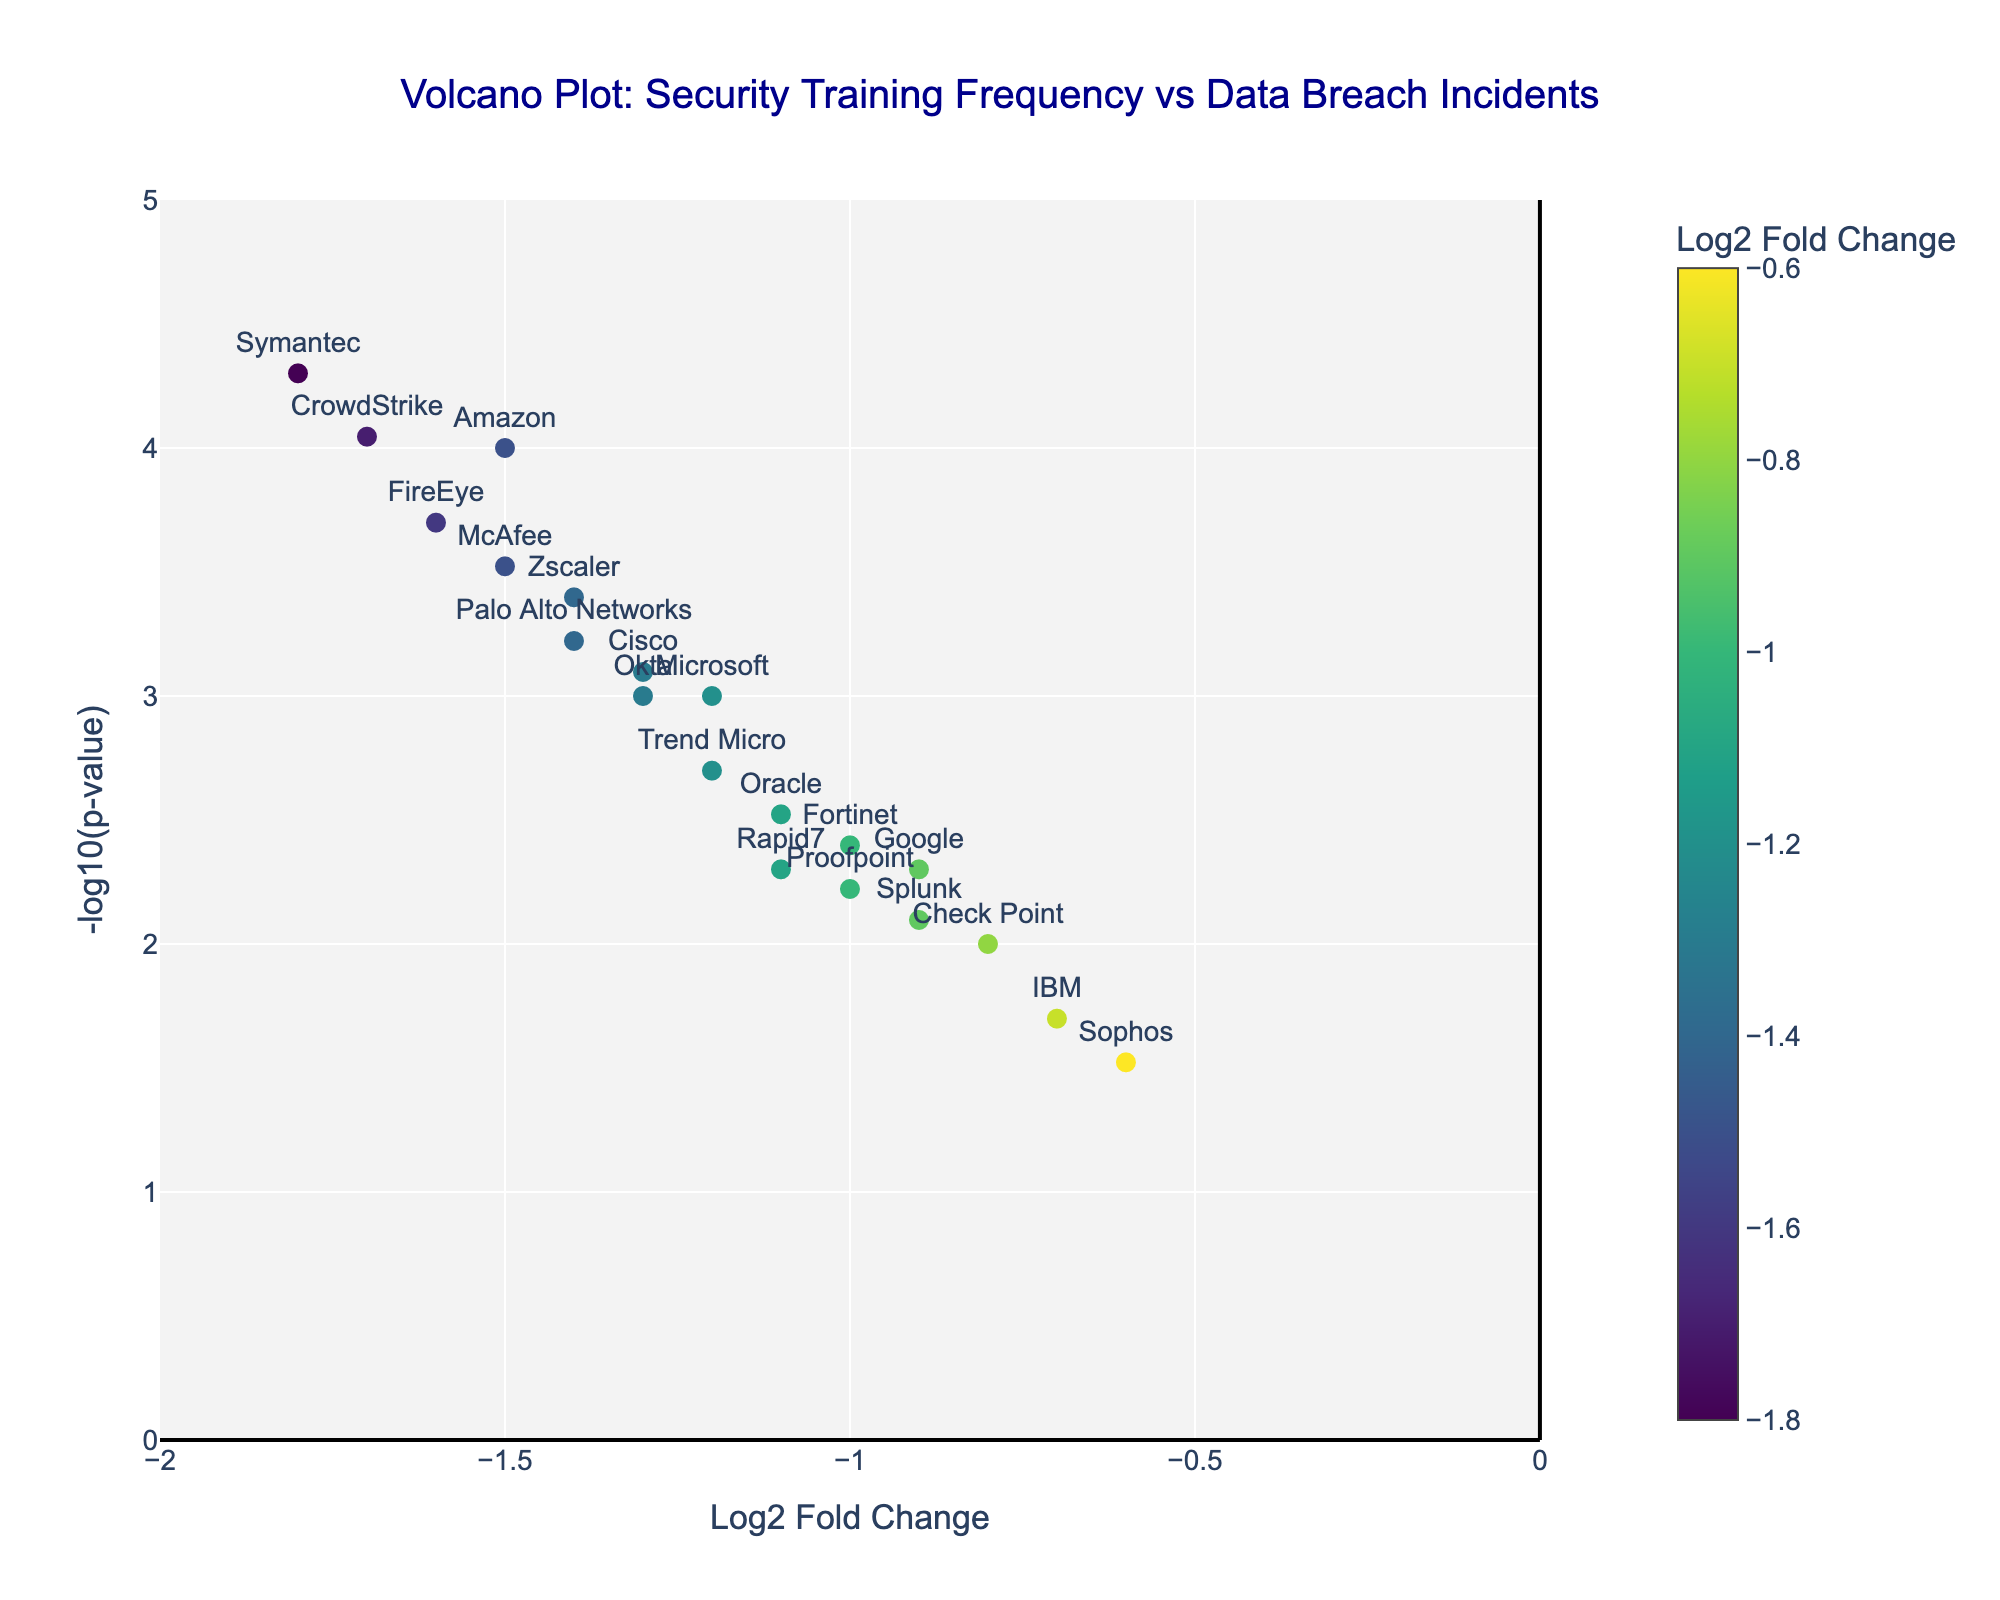What's the title of the figure? The title is usually displayed at the top of the figure. Based on the provided data, the title reads "Volcano Plot: Security Training Frequency vs Data Breach Incidents."
Answer: Volcano Plot: Security Training Frequency vs Data Breach Incidents How many companies are represented in the figure? The number of companies corresponds to the number of data points in the plot. Based on the provided data, there are 20 companies listed.
Answer: 20 What does the x-axis represent? The label of the x-axis indicates what it represents. In this case, the x-axis is labeled "Log2 Fold Change."
Answer: Log2 Fold Change What is the y-axis showing? The label of the y-axis provides this information. In this case, the y-axis is labeled "-log10(p-value)."
Answer: -log10(p-value) Which company has the smallest p-value? The smallest p-value corresponds to the highest point on the y-axis. Symantec has the highest value on the y-axis indicating it has the smallest p-value.
Answer: Symantec What range is specified for the x-axis? The x-axis range can be observed by looking at the numerical limits on the x-axis. The range is specified from -2 to 0.
Answer: -2 to 0 Which company has the highest -log10(p-value) at a Log2 Fold Change of around -1.3? We need to look at the data points around Log2 Fold Change of -1.3 on the x-axis and identify the highest -log10(p-value). Based on the figure, Okta has a high value at this Log2 Fold Change.
Answer: Okta What color is generally used to represent a low Log2 Fold Change value compared to a high one? Colors used in the figure transition according to the Log2 Fold Change values. Generally, a gradient color scale may represent them, usually with darker shades indicating lower values and lighter ones for higher values on a Viridis color scale.
Answer: Darker shades Which companies have a Log2 Fold Change less than -1.5? By looking on the left side of the Log2 Fold Change at specific points below -1.5. Amazon, Symantec, FireEye, CrowdStrike, McAfee fall below -1.5.
Answer: Amazon, Symantec, FireEye, CrowdStrike, McAfee What is the Log2 Fold Change of FireEye? Find FireEye's data point on the x-axis. It is located around -1.6.
Answer: -1.6 